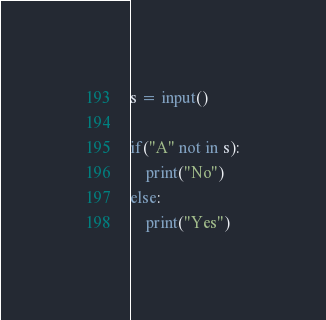<code> <loc_0><loc_0><loc_500><loc_500><_Python_>s = input()

if("A" not in s):
    print("No")
else:
    print("Yes")

</code> 